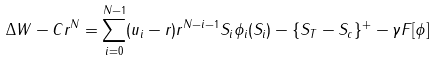Convert formula to latex. <formula><loc_0><loc_0><loc_500><loc_500>\Delta W - C r ^ { N } = \sum _ { i = 0 } ^ { N - 1 } ( u _ { i } - r ) r ^ { N - i - 1 } S _ { i } \phi _ { i } ( S _ { i } ) - \{ S _ { T } - S _ { c } \} ^ { + } - \gamma F [ \phi ]</formula> 